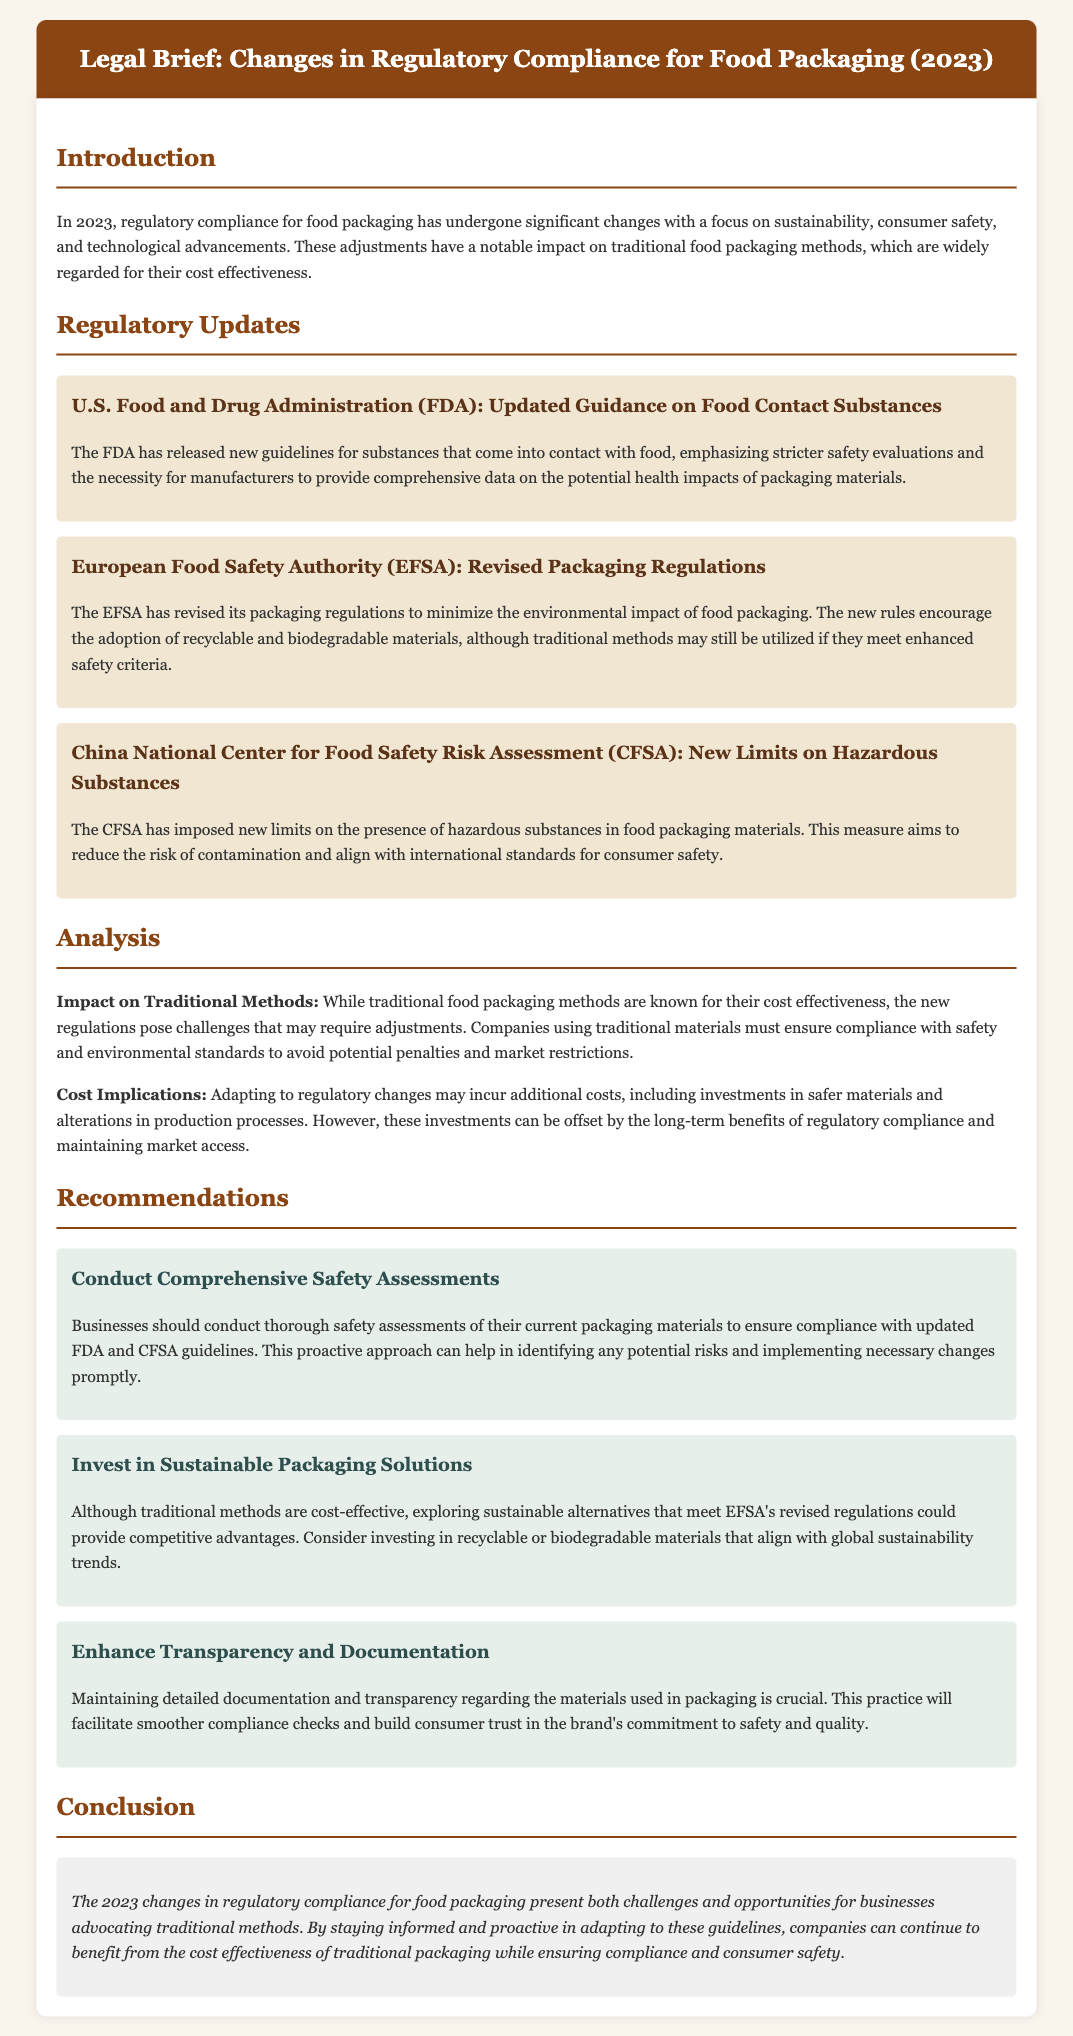What is the focus of the 2023 regulatory changes? The focus of the changes is on sustainability, consumer safety, and technological advancements.
Answer: Sustainability, consumer safety, and technological advancements Which authority released updated guidance on food contact substances? The U.S. Food and Drug Administration (FDA) released the updated guidance.
Answer: U.S. Food and Drug Administration (FDA) What type of materials does the EFSA encourage? The EFSA encourages the adoption of recyclable and biodegradable materials.
Answer: Recyclable and biodegradable materials What must companies ensure when using traditional packaging methods? Companies must ensure compliance with safety and environmental standards.
Answer: Compliance with safety and environmental standards What is a recommendation for businesses regarding packaging materials? Businesses should conduct thorough safety assessments of their current packaging materials.
Answer: Conduct thorough safety assessments How do the new regulations impact traditional food packaging methods? The new regulations pose challenges that may require adjustments.
Answer: Pose challenges that may require adjustments What is one potential benefit of adapting to regulatory changes? One potential benefit is maintaining market access.
Answer: Maintaining market access What is suggested for enhancing consumer trust? Maintaining detailed documentation and transparency regarding the materials used.
Answer: Maintaining detailed documentation and transparency What year are the regulatory changes discussed in the document? The regulatory changes are discussed for the year 2023.
Answer: 2023 